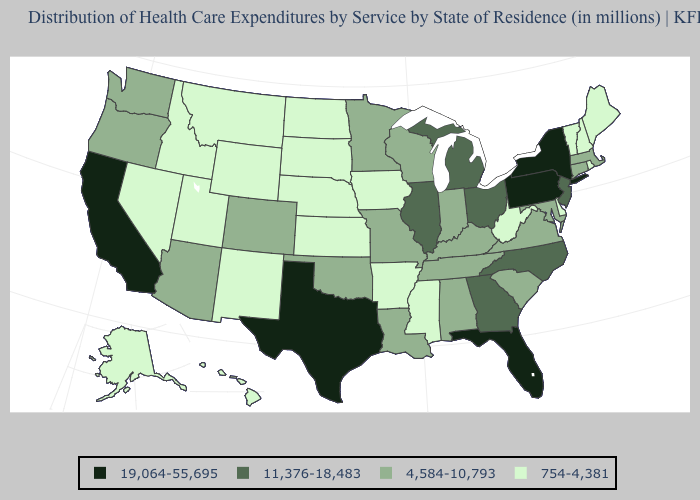What is the value of Vermont?
Quick response, please. 754-4,381. What is the highest value in the USA?
Be succinct. 19,064-55,695. What is the value of California?
Be succinct. 19,064-55,695. Name the states that have a value in the range 19,064-55,695?
Short answer required. California, Florida, New York, Pennsylvania, Texas. Does Oregon have the same value as Texas?
Give a very brief answer. No. Name the states that have a value in the range 19,064-55,695?
Quick response, please. California, Florida, New York, Pennsylvania, Texas. Which states have the highest value in the USA?
Keep it brief. California, Florida, New York, Pennsylvania, Texas. Which states have the lowest value in the South?
Concise answer only. Arkansas, Delaware, Mississippi, West Virginia. Name the states that have a value in the range 754-4,381?
Quick response, please. Alaska, Arkansas, Delaware, Hawaii, Idaho, Iowa, Kansas, Maine, Mississippi, Montana, Nebraska, Nevada, New Hampshire, New Mexico, North Dakota, Rhode Island, South Dakota, Utah, Vermont, West Virginia, Wyoming. How many symbols are there in the legend?
Keep it brief. 4. Does New Hampshire have the lowest value in the Northeast?
Answer briefly. Yes. What is the value of Iowa?
Write a very short answer. 754-4,381. Which states have the lowest value in the Northeast?
Give a very brief answer. Maine, New Hampshire, Rhode Island, Vermont. Which states have the highest value in the USA?
Short answer required. California, Florida, New York, Pennsylvania, Texas. Does Pennsylvania have the lowest value in the Northeast?
Concise answer only. No. 